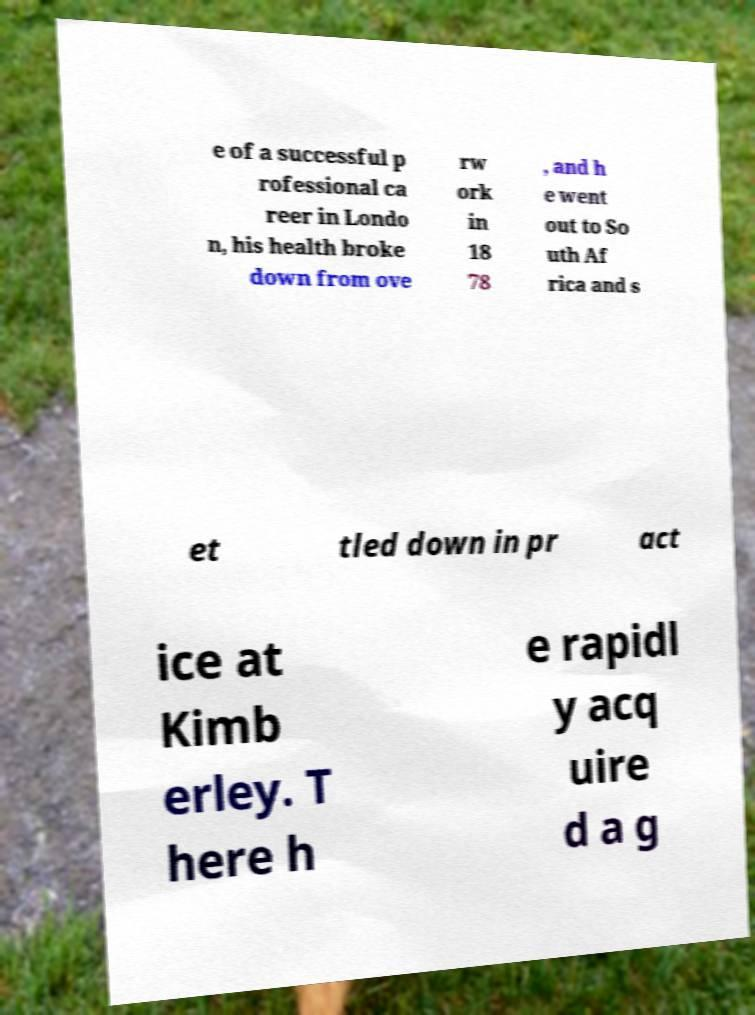Please identify and transcribe the text found in this image. e of a successful p rofessional ca reer in Londo n, his health broke down from ove rw ork in 18 78 , and h e went out to So uth Af rica and s et tled down in pr act ice at Kimb erley. T here h e rapidl y acq uire d a g 